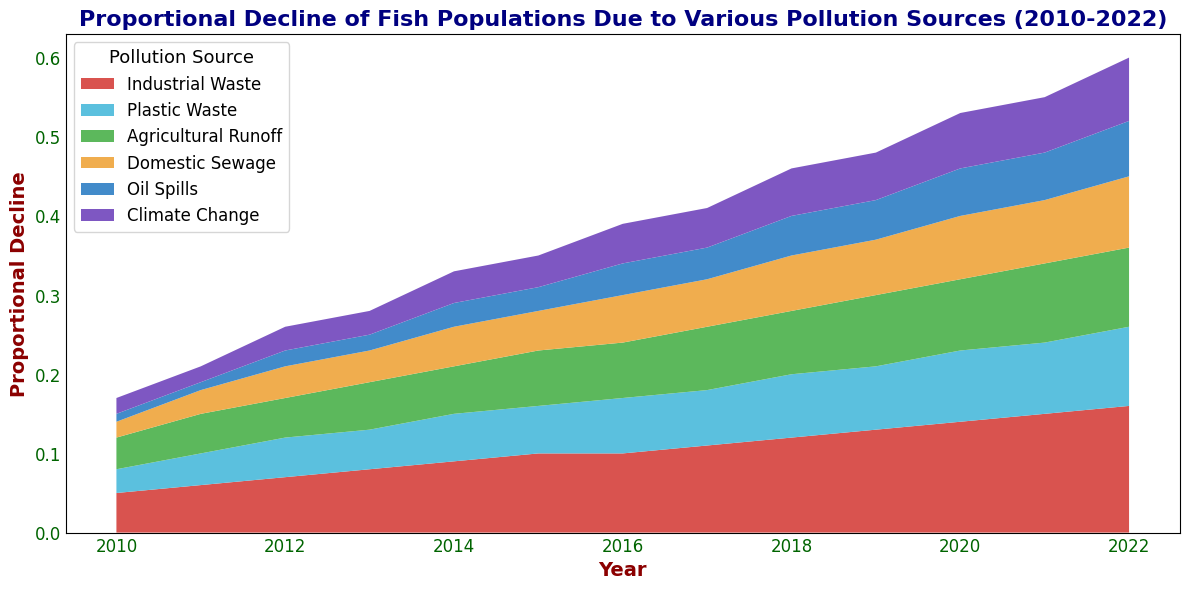what is the source of pollution with the smallest contribution to the proportional decline of fish populations in 2010? By looking at the chart for the year 2010, observe the segments of the area plot. The smallest segment represents the smallest proportional contribution.
Answer: Oil Spills Which pollution source showed the steepest increase in its contribution proportionally from 2010 to 2022? To determine the steepest increase, calculate the difference in proportions for each source between 2010 and 2022, then compare values.
Answer: Industrial Waste What is the combined proportional decline due to Agricultural Runoff and Domestic Sewage in 2015? Sum the 2015 values for Agricultural Runoff (0.07) and Domestic Sewage (0.05) from the area chart.
Answer: 0.12 Between which consecutive years did Plastic Waste's proportional decline show the largest increase? Examine the increments year-on-year of Plastic Waste, then identify the largest one.
Answer: 2011-2012 Which pollution source's proportional decline maintains the most consistent trend over the years? Look for the source with the flattest area change over the years; less variation implies more consistency.
Answer: Climate Change By how much did the proportional decline due to Oil Spills change from 2017 to 2021? Subtract the 2017 value (0.04) from the 2021 value (0.06).
Answer: 0.02 Which pollution sources surpassed the 0.10 proportional decline mark in 2022? Identify the segments with values above 0.10 on the 2022 axis.
Answer: Industrial Waste and Agricultural Runoff What is the total proportional decline in fish populations due to all pollution sources combined in 2013? Sum all proportional values for 2013: (0.08 + 0.05 + 0.06 + 0.04 + 0.02 + 0.03).
Answer: 0.28 Is there any pollution source whose contribution proportionally does not increase at any year? Check each pollution source for any year-on-year non-increasing trend.
Answer: No 